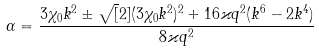<formula> <loc_0><loc_0><loc_500><loc_500>\alpha = \frac { 3 \chi _ { 0 } k ^ { 2 } \pm \sqrt { [ } 2 ] { ( 3 \chi _ { 0 } k ^ { 2 } ) ^ { 2 } + 1 6 \varkappa q ^ { 2 } ( k ^ { 6 } - 2 k ^ { 4 } ) } } { 8 \varkappa q ^ { 2 } }</formula> 